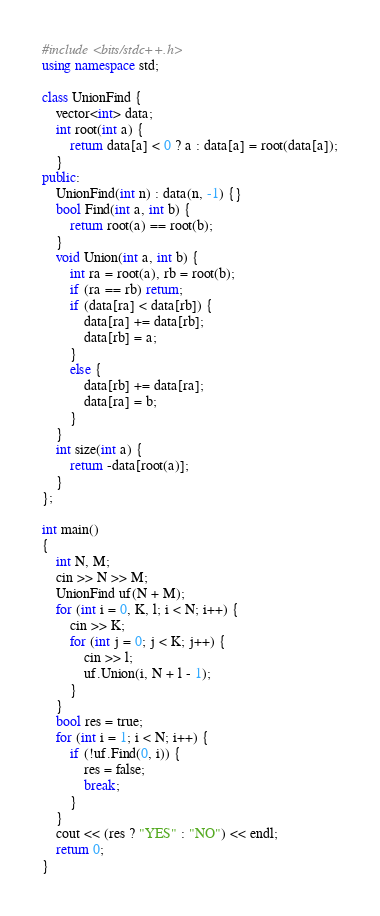<code> <loc_0><loc_0><loc_500><loc_500><_C++_>#include <bits/stdc++.h>
using namespace std;

class UnionFind {
	vector<int> data;
	int root(int a) {
		return data[a] < 0 ? a : data[a] = root(data[a]);
	}
public:
	UnionFind(int n) : data(n, -1) {}
	bool Find(int a, int b) {
		return root(a) == root(b);
	}
	void Union(int a, int b) {
		int ra = root(a), rb = root(b);
		if (ra == rb) return;
		if (data[ra] < data[rb]) {
			data[ra] += data[rb];
			data[rb] = a;
		}
		else {
			data[rb] += data[ra];
			data[ra] = b;
		}
	}
	int size(int a) {
		return -data[root(a)];
	}
};

int main()
{
	int N, M;
	cin >> N >> M;
	UnionFind uf(N + M);
	for (int i = 0, K, l; i < N; i++) {
		cin >> K;
		for (int j = 0; j < K; j++) {
			cin >> l;
			uf.Union(i, N + l - 1);
		}
	}
	bool res = true;
	for (int i = 1; i < N; i++) {
		if (!uf.Find(0, i)) {
			res = false;
			break;
		}
	}
	cout << (res ? "YES" : "NO") << endl;
	return 0;
}
</code> 